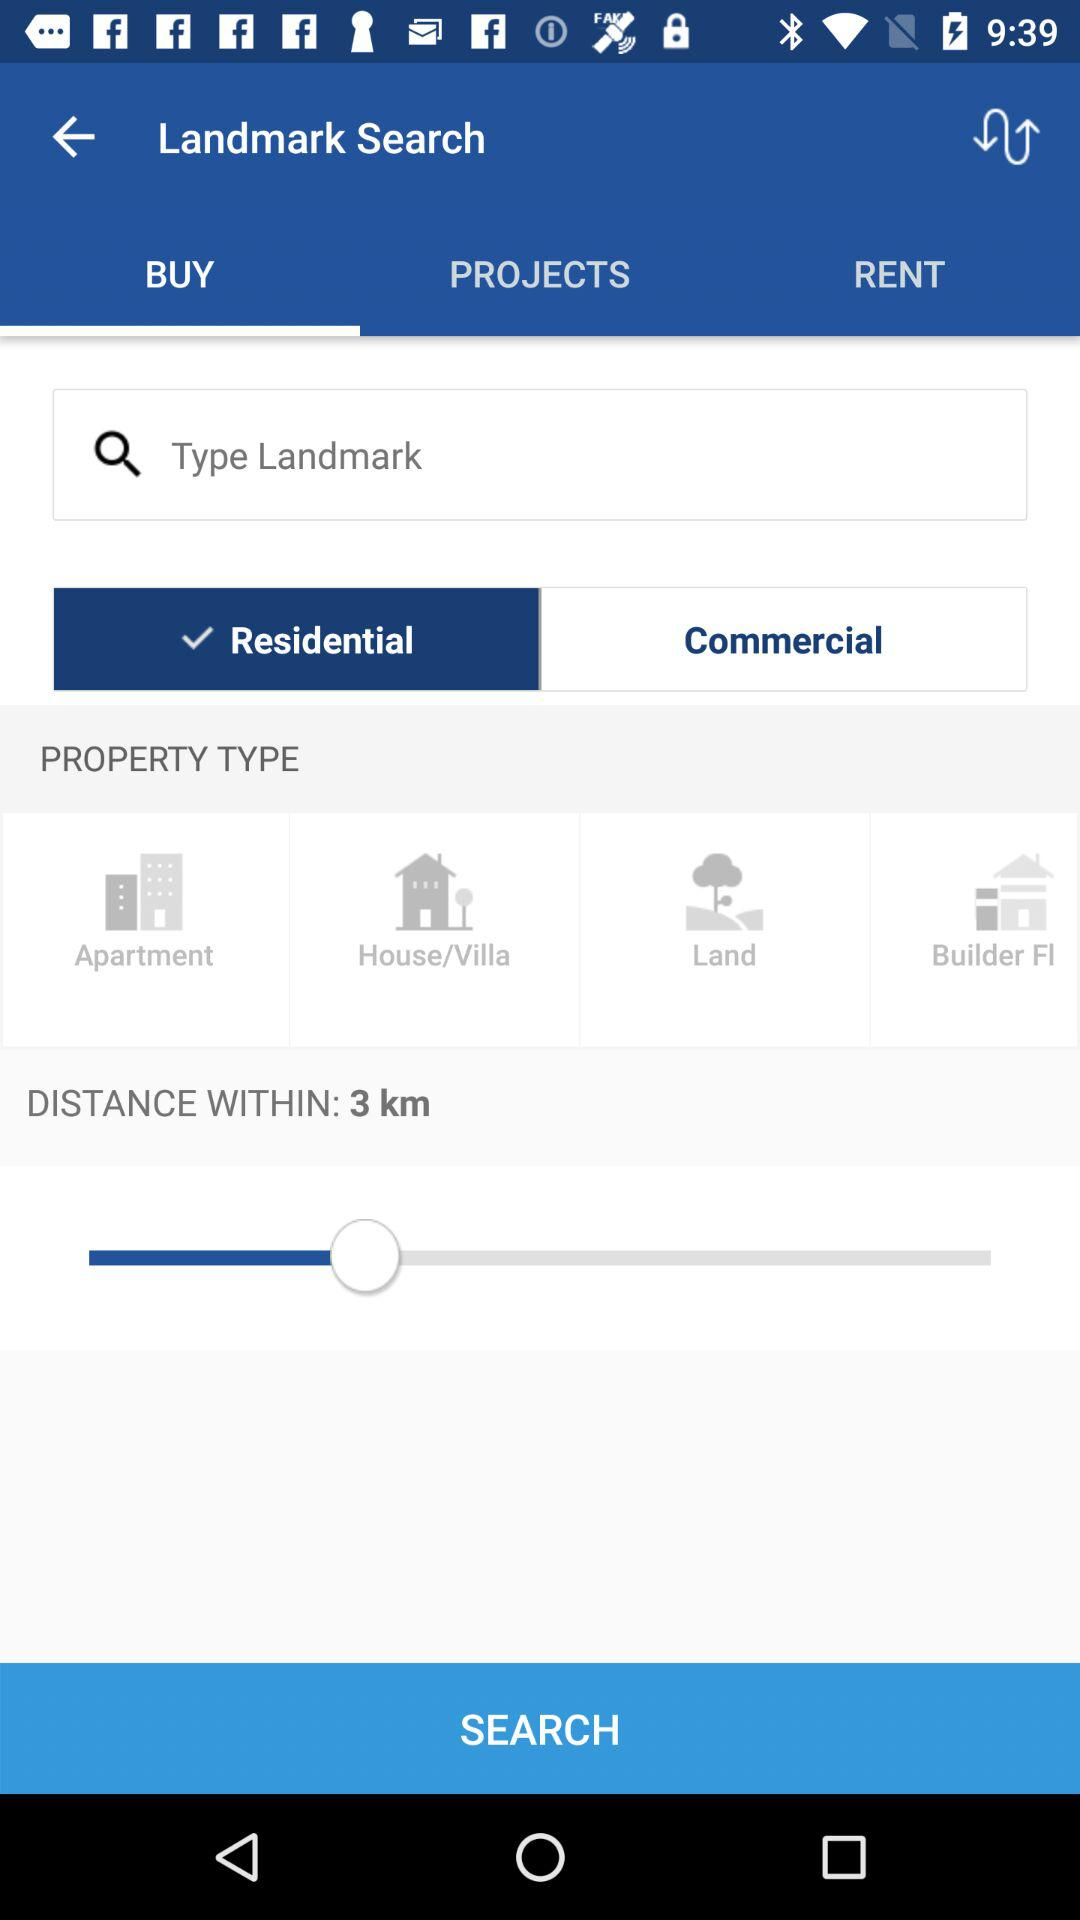How many property types are available to search for?
Answer the question using a single word or phrase. 4 